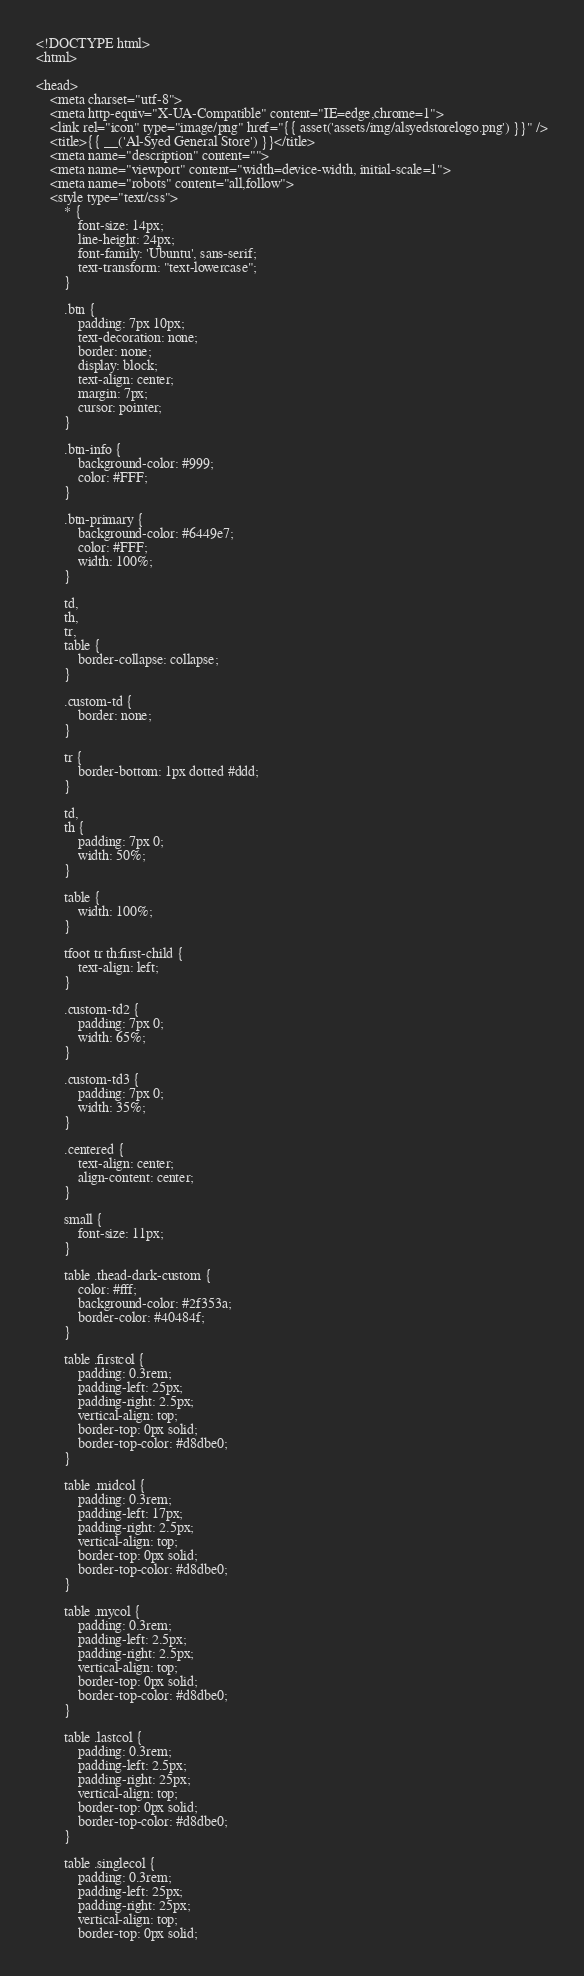Convert code to text. <code><loc_0><loc_0><loc_500><loc_500><_PHP_><!DOCTYPE html>
<html>

<head>
    <meta charset="utf-8">
    <meta http-equiv="X-UA-Compatible" content="IE=edge,chrome=1">
    <link rel="icon" type="image/png" href="{{ asset('assets/img/alsyedstorelogo.png') }}" />
    <title>{{ __('Al-Syed General Store') }}</title>
    <meta name="description" content="">
    <meta name="viewport" content="width=device-width, initial-scale=1">
    <meta name="robots" content="all,follow">
    <style type="text/css">
        * {
            font-size: 14px;
            line-height: 24px;
            font-family: 'Ubuntu', sans-serif;
            text-transform: "text-lowercase";
        }

        .btn {
            padding: 7px 10px;
            text-decoration: none;
            border: none;
            display: block;
            text-align: center;
            margin: 7px;
            cursor: pointer;
        }

        .btn-info {
            background-color: #999;
            color: #FFF;
        }

        .btn-primary {
            background-color: #6449e7;
            color: #FFF;
            width: 100%;
        }

        td,
        th,
        tr,
        table {
            border-collapse: collapse;
        }

        .custom-td {
            border: none;
        }

        tr {
            border-bottom: 1px dotted #ddd;
        }

        td,
        th {
            padding: 7px 0;
            width: 50%;
        }

        table {
            width: 100%;
        }

        tfoot tr th:first-child {
            text-align: left;
        }

        .custom-td2 {
            padding: 7px 0;
            width: 65%;
        }

        .custom-td3 {
            padding: 7px 0;
            width: 35%;
        }

        .centered {
            text-align: center;
            align-content: center;
        }

        small {
            font-size: 11px;
        }

        table .thead-dark-custom {
            color: #fff;
            background-color: #2f353a;
            border-color: #40484f;
        }

        table .firstcol {
            padding: 0.3rem;
            padding-left: 25px;
            padding-right: 2.5px;
            vertical-align: top;
            border-top: 0px solid;
            border-top-color: #d8dbe0;
        }

        table .midcol {
            padding: 0.3rem;
            padding-left: 17px;
            padding-right: 2.5px;
            vertical-align: top;
            border-top: 0px solid;
            border-top-color: #d8dbe0;
        }

        table .mycol {
            padding: 0.3rem;
            padding-left: 2.5px;
            padding-right: 2.5px;
            vertical-align: top;
            border-top: 0px solid;
            border-top-color: #d8dbe0;
        }

        table .lastcol {
            padding: 0.3rem;
            padding-left: 2.5px;
            padding-right: 25px;
            vertical-align: top;
            border-top: 0px solid;
            border-top-color: #d8dbe0;
        }

        table .singlecol {
            padding: 0.3rem;
            padding-left: 25px;
            padding-right: 25px;
            vertical-align: top;
            border-top: 0px solid;</code> 